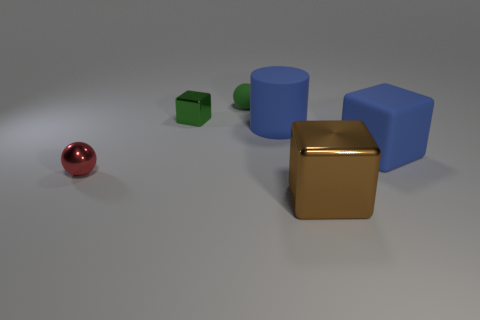Add 1 small cyan rubber blocks. How many objects exist? 7 Subtract all balls. How many objects are left? 4 Add 1 large metallic blocks. How many large metallic blocks exist? 2 Subtract 1 blue blocks. How many objects are left? 5 Subtract all big yellow shiny cubes. Subtract all large shiny blocks. How many objects are left? 5 Add 1 large shiny cubes. How many large shiny cubes are left? 2 